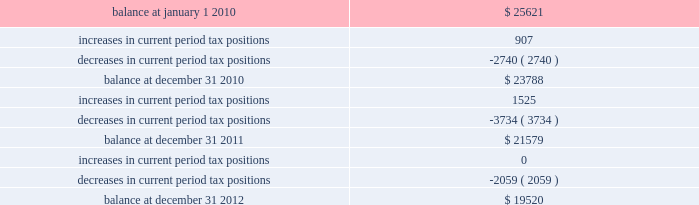The table summarizes the changes in the company 2019s valuation allowance: .
Note 14 : employee benefits pension and other postretirement benefits the company maintains noncontributory defined benefit pension plans covering eligible employees of its regulated utility and shared services operations .
Benefits under the plans are based on the employee 2019s years of service and compensation .
The pension plans have been closed for most employees hired on or after january 1 , 2006 .
Union employees hired on or after january 1 , 2001 had their accrued benefit frozen and will be able to receive this benefit as a lump sum upon termination or retirement .
Union employees hired on or after january 1 , 2001 and non-union employees hired on or after january 1 , 2006 are provided with a 5.25% ( 5.25 % ) of base pay defined contribution plan .
The company does not participate in a multiemployer plan .
The company 2019s funding policy is to contribute at least the greater of the minimum amount required by the employee retirement income security act of 1974 or the normal cost , and an additional contribution if needed to avoid 201cat risk 201d status and benefit restrictions under the pension protection act of 2006 .
The company may also increase its contributions , if appropriate , to its tax and cash position and the plan 2019s funded position .
Pension plan assets are invested in a number of actively managed and indexed investments including equity and bond mutual funds , fixed income securities and guaranteed interest contracts with insurance companies .
Pension expense in excess of the amount contributed to the pension plans is deferred by certain regulated subsidiaries pending future recovery in rates charged for utility services as contributions are made to the plans .
( see note 6 ) the company also has several unfunded noncontributory supplemental non-qualified pension plans that provide additional retirement benefits to certain employees .
The company maintains other postretirement benefit plans providing varying levels of medical and life insurance to eligible retirees .
The retiree welfare plans are closed for union employees hired on or after january 1 , 2006 .
The plans had previously closed for non-union employees hired on or after january 1 , 2002 .
The company 2019s policy is to fund other postretirement benefit costs for rate-making purposes .
Plan assets are invested in equity and bond mutual funds , fixed income securities , real estate investment trusts ( 201creits 201d ) and emerging market funds .
The obligations of the plans are dominated by obligations for active employees .
Because the timing of expected benefit payments is so far in the future and the size of the plan assets are small relative to the company 2019s assets , the investment strategy is to allocate a significant percentage of assets to equities , which the company believes will provide the highest return over the long-term period .
The fixed income assets are invested in long duration debt securities and may be invested in fixed income instruments , such as futures and options in order to better match the duration of the plan liability. .
As of december 312012 what was the percentage change in tax positions from 2011 and favorable or unfavorable? 
Rationale: the change in tax position from year to year is the ( end balance less begin balance ) divide by the begin balance
Computations: ((2059 * const_m1) / 21579)
Answer: -0.09542. 